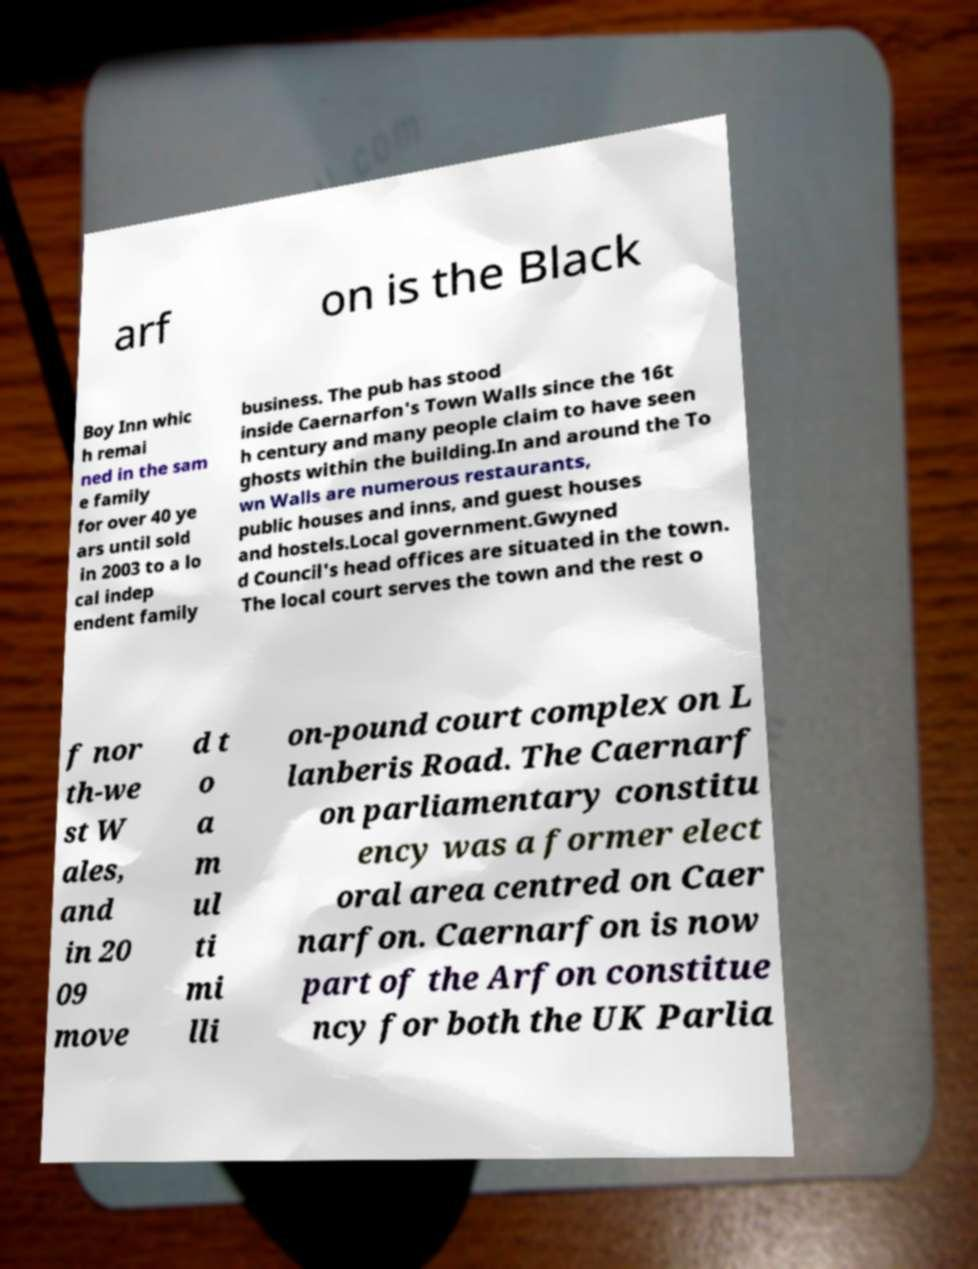There's text embedded in this image that I need extracted. Can you transcribe it verbatim? arf on is the Black Boy Inn whic h remai ned in the sam e family for over 40 ye ars until sold in 2003 to a lo cal indep endent family business. The pub has stood inside Caernarfon's Town Walls since the 16t h century and many people claim to have seen ghosts within the building.In and around the To wn Walls are numerous restaurants, public houses and inns, and guest houses and hostels.Local government.Gwyned d Council's head offices are situated in the town. The local court serves the town and the rest o f nor th-we st W ales, and in 20 09 move d t o a m ul ti mi lli on-pound court complex on L lanberis Road. The Caernarf on parliamentary constitu ency was a former elect oral area centred on Caer narfon. Caernarfon is now part of the Arfon constitue ncy for both the UK Parlia 